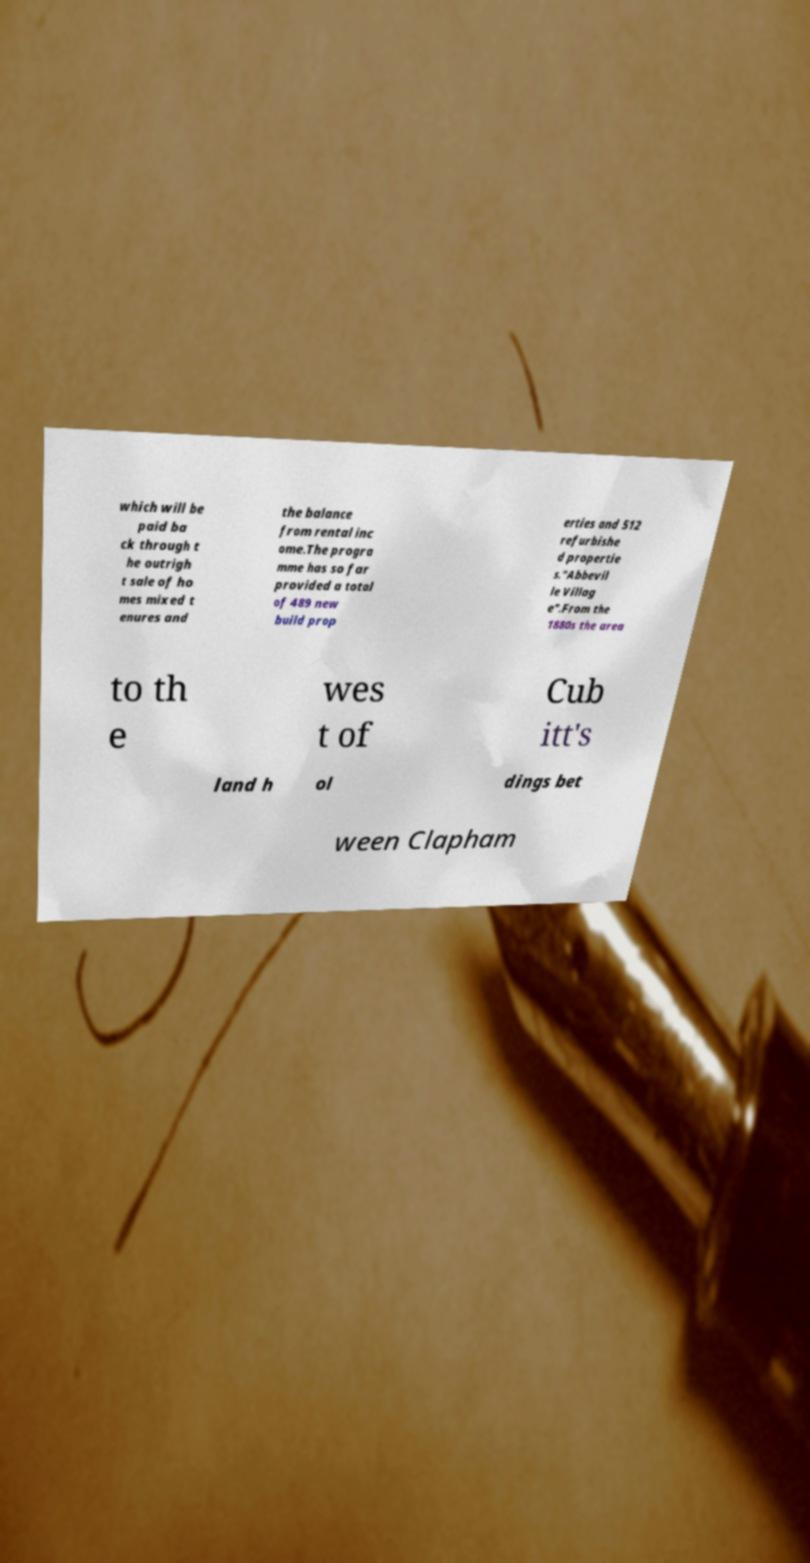What messages or text are displayed in this image? I need them in a readable, typed format. which will be paid ba ck through t he outrigh t sale of ho mes mixed t enures and the balance from rental inc ome.The progra mme has so far provided a total of 489 new build prop erties and 512 refurbishe d propertie s."Abbevil le Villag e".From the 1880s the area to th e wes t of Cub itt's land h ol dings bet ween Clapham 